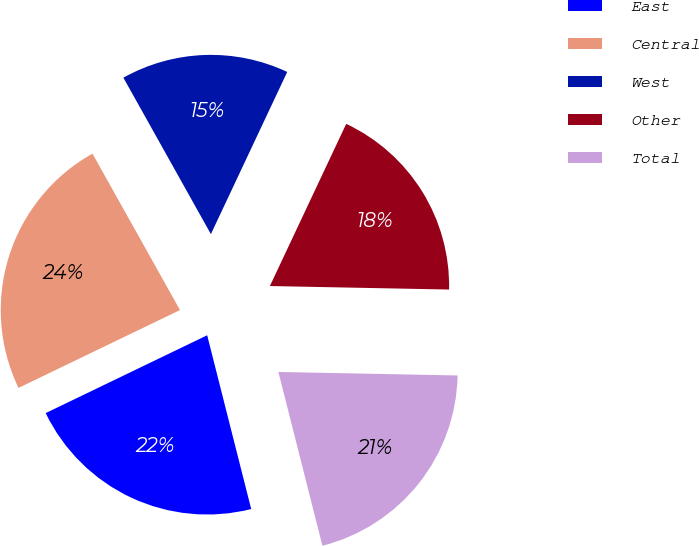<chart> <loc_0><loc_0><loc_500><loc_500><pie_chart><fcel>East<fcel>Central<fcel>West<fcel>Other<fcel>Total<nl><fcel>21.8%<fcel>24.03%<fcel>15.12%<fcel>18.31%<fcel>20.74%<nl></chart> 